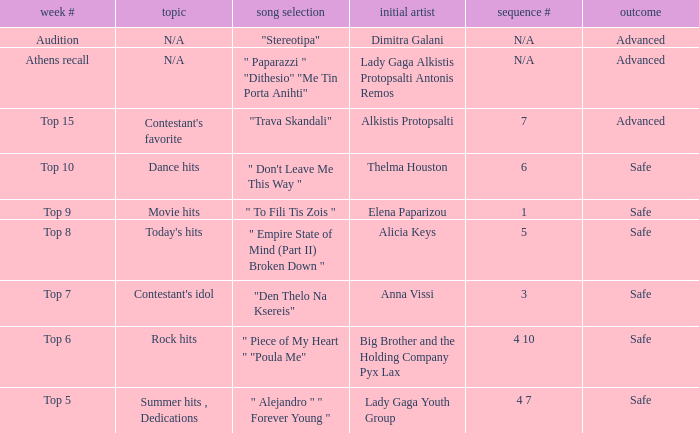Which artists have order # 1? Elena Paparizou. 